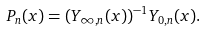<formula> <loc_0><loc_0><loc_500><loc_500>P _ { n } ( x ) = ( Y _ { \infty , n } ( x ) ) ^ { - 1 } Y _ { 0 , n } ( x ) .</formula> 